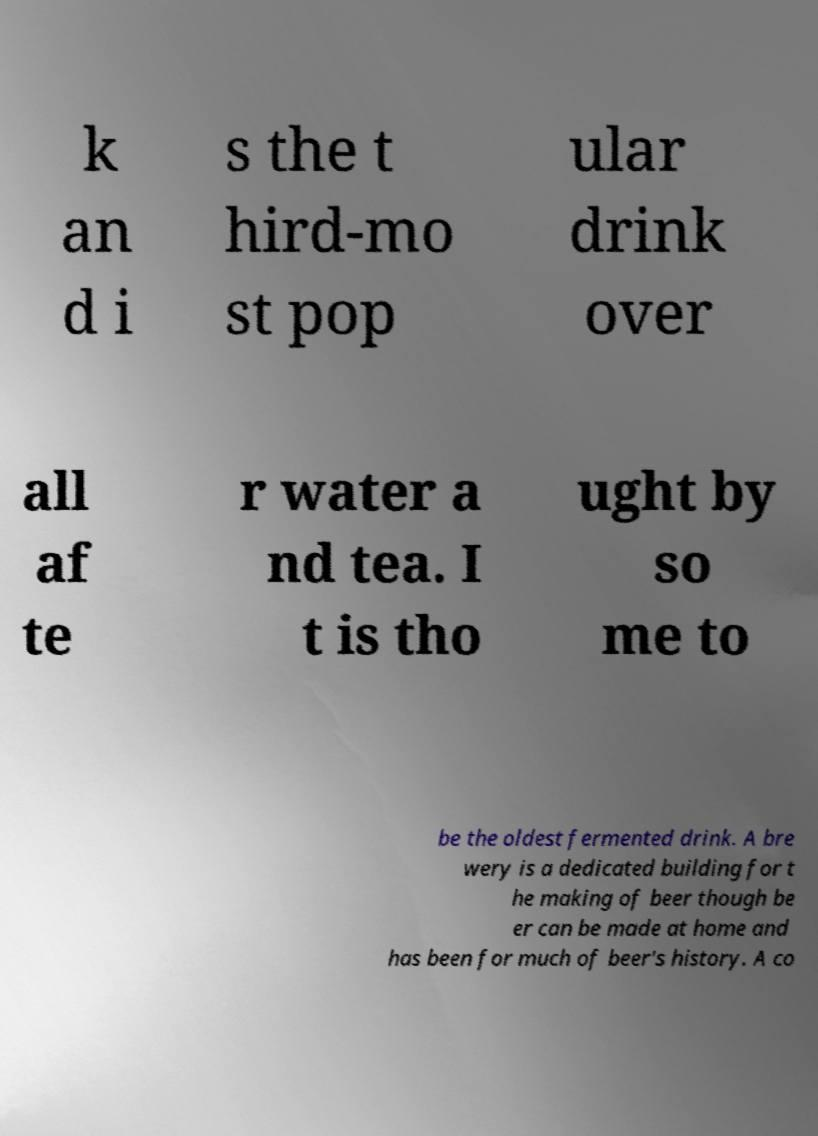I need the written content from this picture converted into text. Can you do that? k an d i s the t hird-mo st pop ular drink over all af te r water a nd tea. I t is tho ught by so me to be the oldest fermented drink. A bre wery is a dedicated building for t he making of beer though be er can be made at home and has been for much of beer's history. A co 